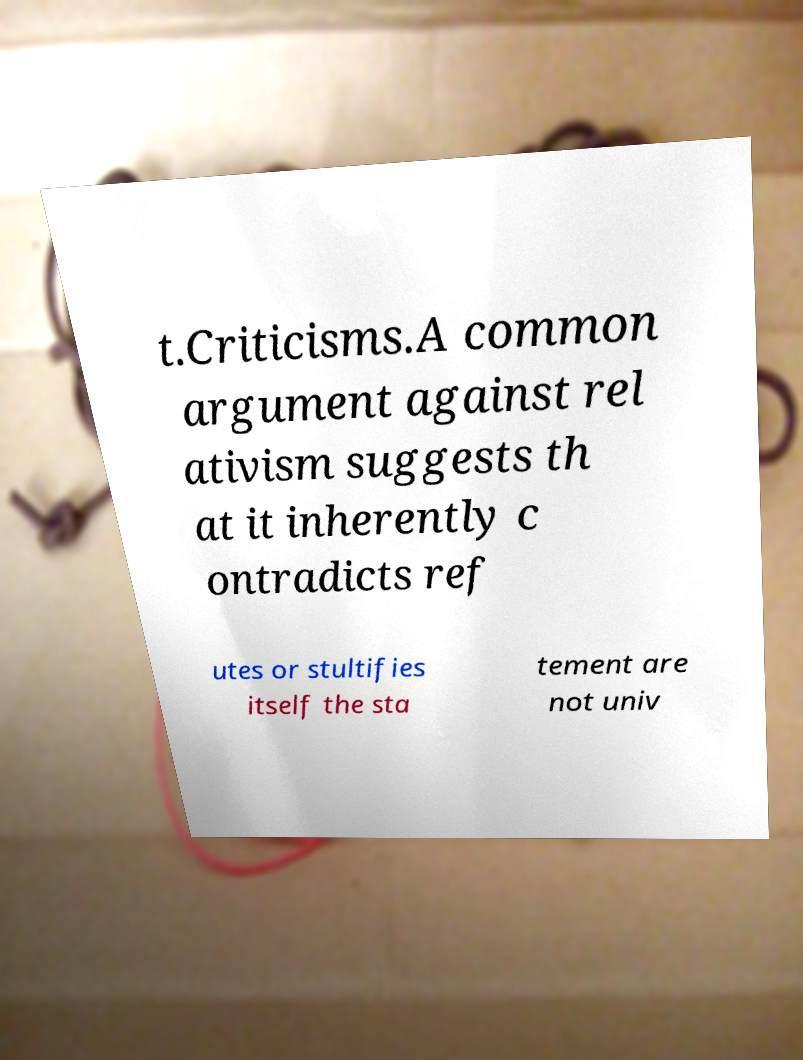There's text embedded in this image that I need extracted. Can you transcribe it verbatim? t.Criticisms.A common argument against rel ativism suggests th at it inherently c ontradicts ref utes or stultifies itself the sta tement are not univ 